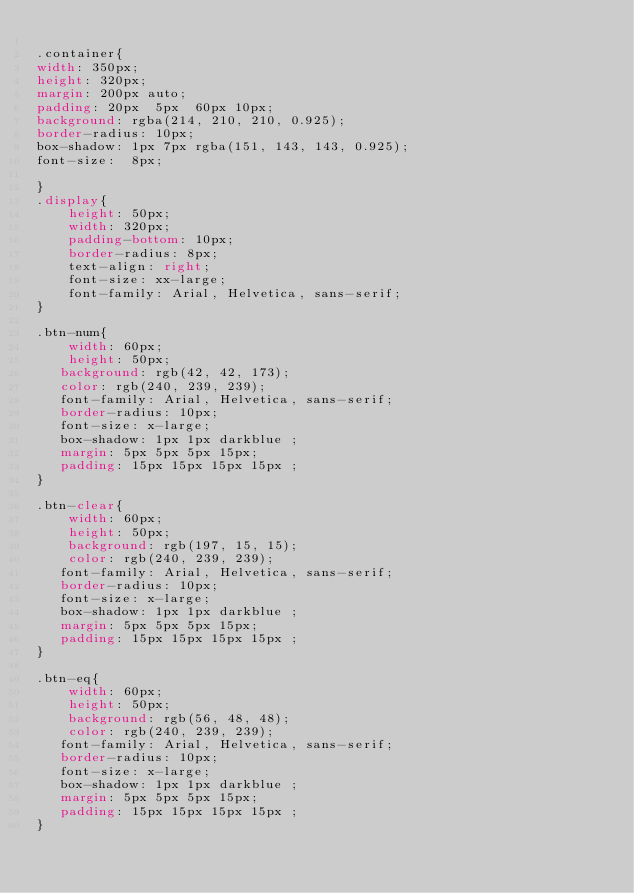Convert code to text. <code><loc_0><loc_0><loc_500><loc_500><_CSS_>
.container{
width: 350px;
height: 320px;
margin: 200px auto;
padding: 20px  5px  60px 10px;
background: rgba(214, 210, 210, 0.925);
border-radius: 10px;
box-shadow: 1px 7px rgba(151, 143, 143, 0.925);
font-size:  8px;

}
.display{
    height: 50px;
    width: 320px;
    padding-bottom: 10px;
    border-radius: 8px;
    text-align: right;
    font-size: xx-large;
    font-family: Arial, Helvetica, sans-serif;
}

.btn-num{
    width: 60px;
    height: 50px;
   background: rgb(42, 42, 173);
   color: rgb(240, 239, 239);
   font-family: Arial, Helvetica, sans-serif;
   border-radius: 10px;
   font-size: x-large;
   box-shadow: 1px 1px darkblue ;
   margin: 5px 5px 5px 15px;
   padding: 15px 15px 15px 15px ;
}

.btn-clear{
    width: 60px;
    height: 50px;
    background: rgb(197, 15, 15);
    color: rgb(240, 239, 239);
   font-family: Arial, Helvetica, sans-serif;
   border-radius: 10px;
   font-size: x-large;
   box-shadow: 1px 1px darkblue ;
   margin: 5px 5px 5px 15px;
   padding: 15px 15px 15px 15px ;
}

.btn-eq{
    width: 60px;
    height: 50px;
    background: rgb(56, 48, 48);
    color: rgb(240, 239, 239);
   font-family: Arial, Helvetica, sans-serif;
   border-radius: 10px;
   font-size: x-large;
   box-shadow: 1px 1px darkblue ;
   margin: 5px 5px 5px 15px;
   padding: 15px 15px 15px 15px ;
}</code> 